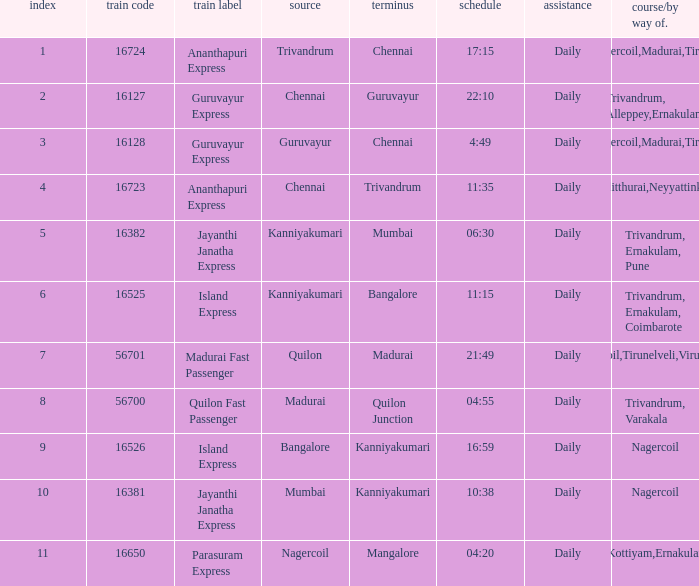What is the origin when the destination is Mumbai? Kanniyakumari. 